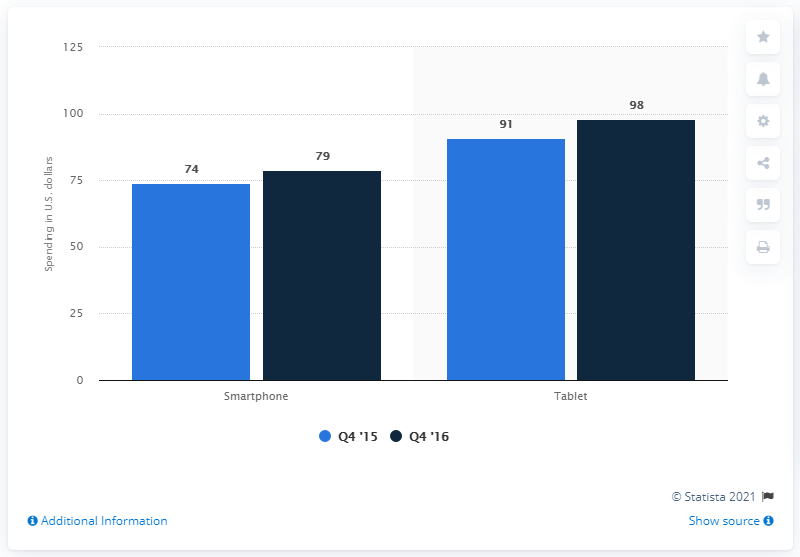Outline some significant characteristics in this image. During the last measured period, the average amount spent per tablet e-retail transaction was approximately $98. 